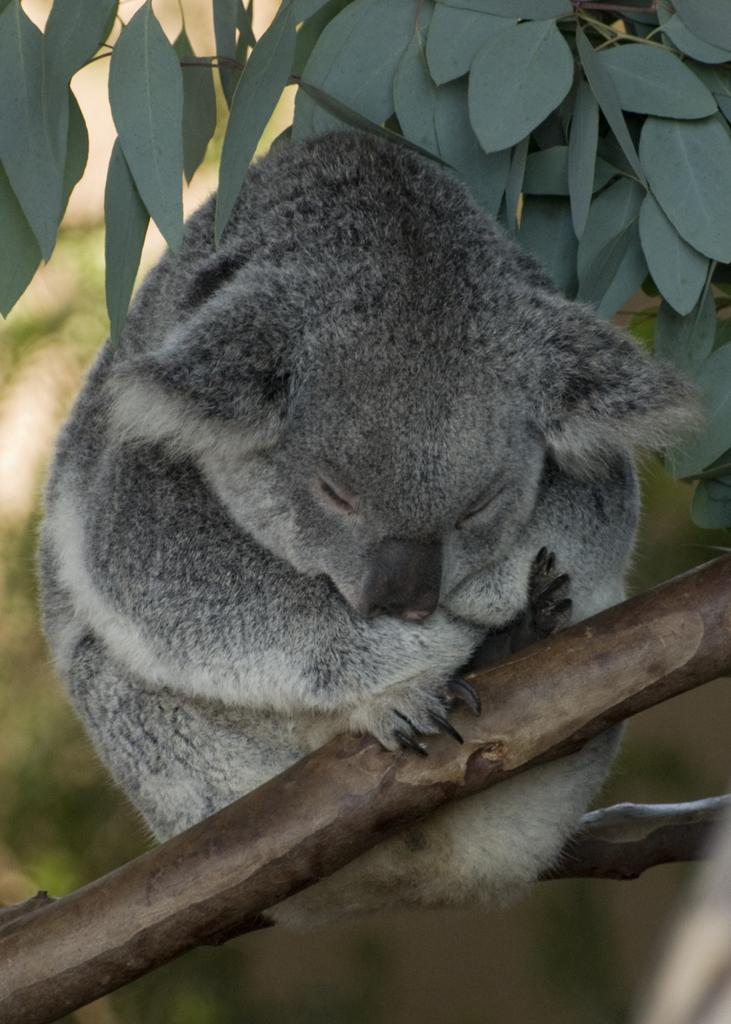What type of animal can be seen in the image? There is an animal in the image, but its specific type cannot be determined from the provided facts. Where is the animal located in the image? The animal is on a branch in the image. What else can be seen in the image besides the animal? There are leaves in the image. What type of ray is visible in the image? There is no ray present in the image; it features an animal on a branch and leaves. Can you tell me how many divisions are present in the image? The concept of divisions is not applicable to the image, as it does not involve any mathematical or structural elements. 